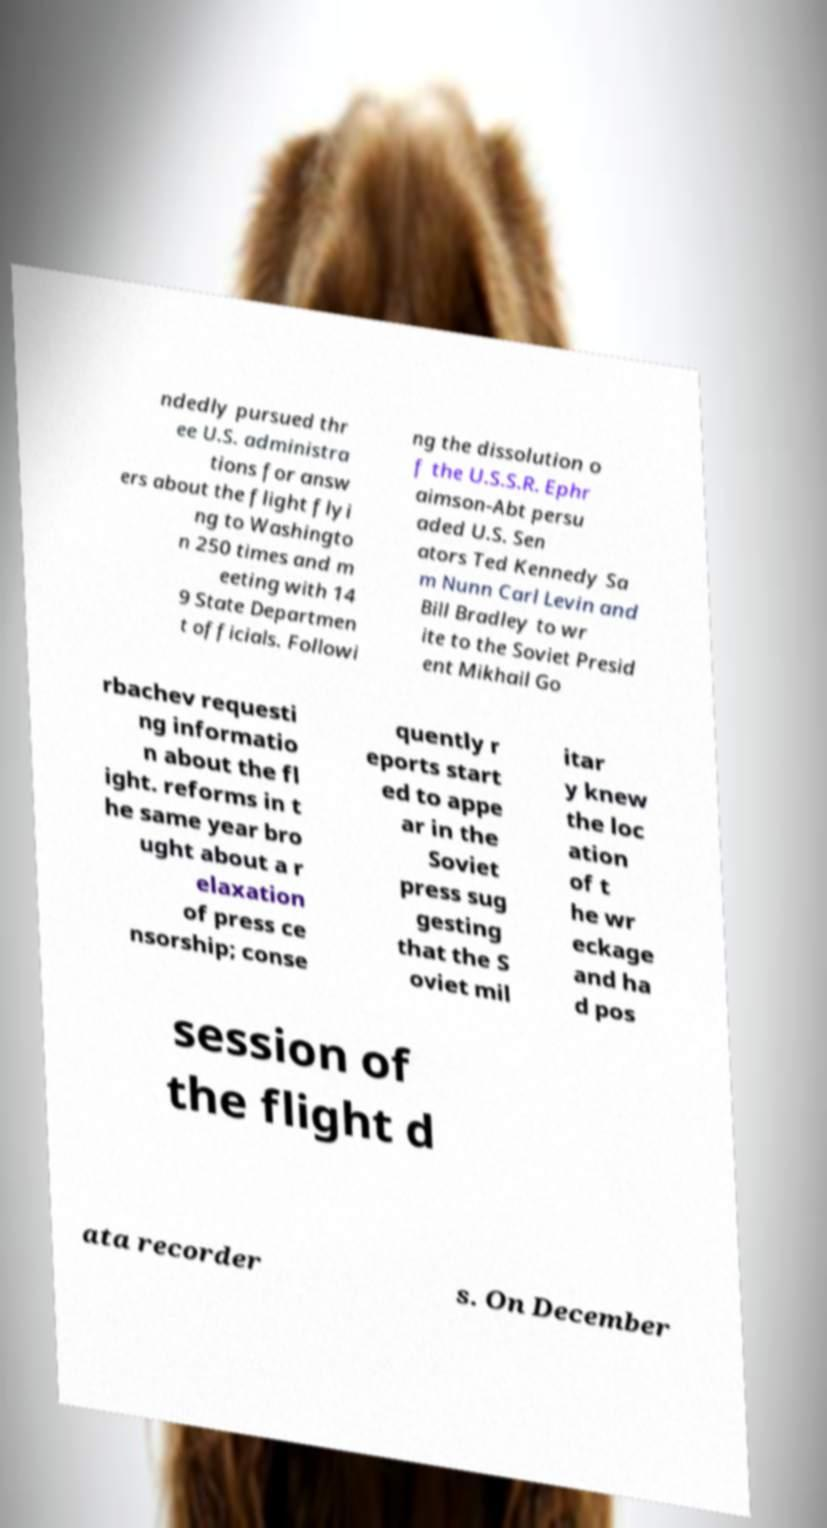For documentation purposes, I need the text within this image transcribed. Could you provide that? ndedly pursued thr ee U.S. administra tions for answ ers about the flight flyi ng to Washingto n 250 times and m eeting with 14 9 State Departmen t officials. Followi ng the dissolution o f the U.S.S.R. Ephr aimson-Abt persu aded U.S. Sen ators Ted Kennedy Sa m Nunn Carl Levin and Bill Bradley to wr ite to the Soviet Presid ent Mikhail Go rbachev requesti ng informatio n about the fl ight. reforms in t he same year bro ught about a r elaxation of press ce nsorship; conse quently r eports start ed to appe ar in the Soviet press sug gesting that the S oviet mil itar y knew the loc ation of t he wr eckage and ha d pos session of the flight d ata recorder s. On December 